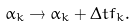Convert formula to latex. <formula><loc_0><loc_0><loc_500><loc_500>\alpha _ { k } \to \alpha _ { k } + \Delta t f _ { k } .</formula> 